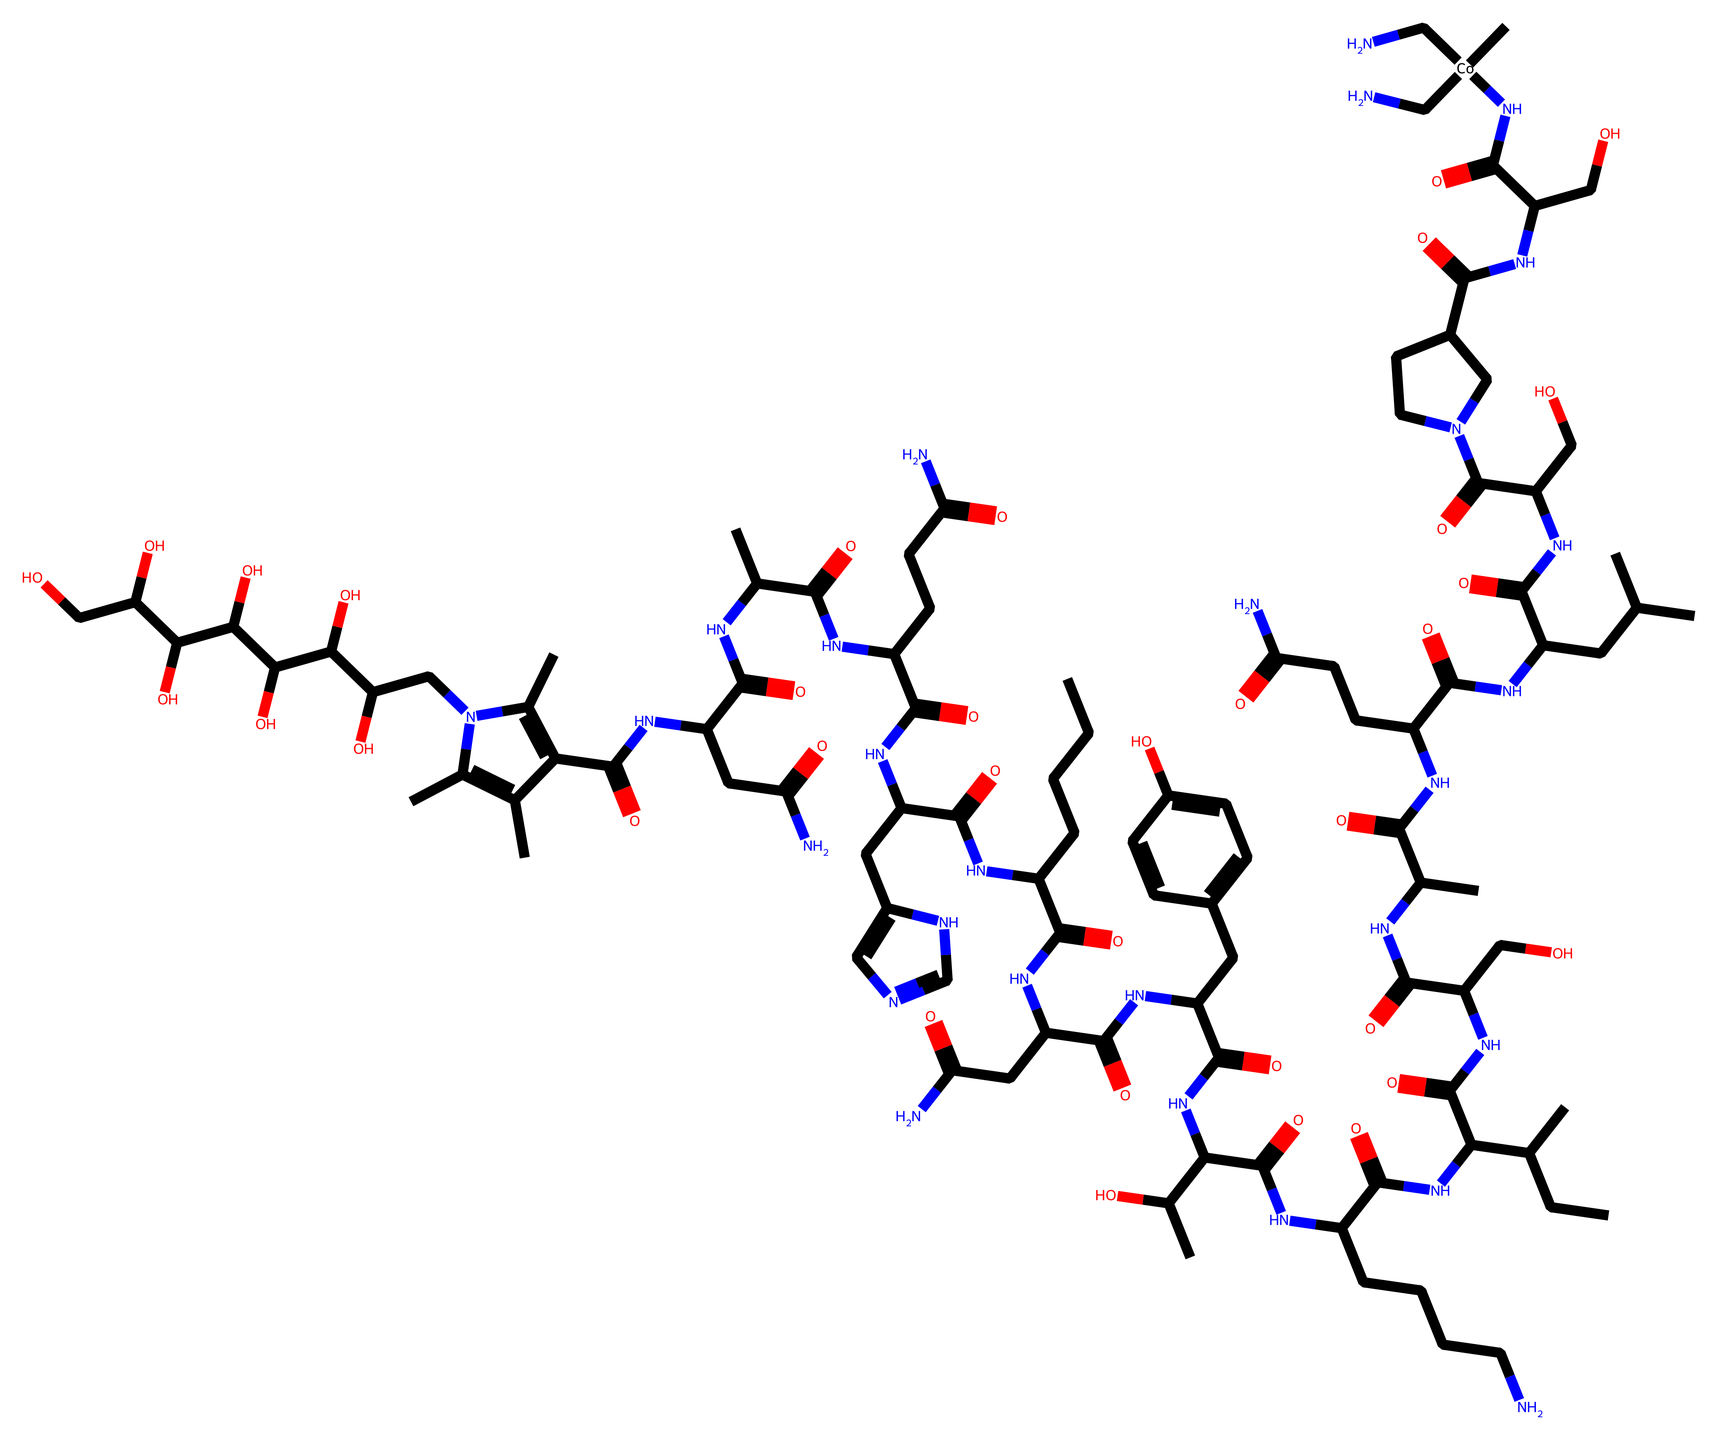What is the central metal in this organometallic compound? The structure includes cobalt (Co) directly connected to the nitrogen atoms from the side chains, indicating that cobalt is the central metal in this compound.
Answer: cobalt How many nitrogen atoms are present in the structure? By inspecting the SMILES representation, there are several nitrogen atoms indicated by the 'N' letter, totaling five distinct nitrogen atoms at various parts of the structure.
Answer: five Is this compound a part of any vitamin category? The compound structure corresponds to methylcobalamin, which is known to be a form of Vitamin B12, indicating that this chemical is indeed part of a vitamin category.
Answer: Vitamin B12 What functional groups are prominent in this chemical? The presence of multiple hydroxyl (-OH) groups and amide (R-C(=O)N-R') linkages suggests that these are the most prominent functional groups present in the compound.
Answer: hydroxyl and amide How does the cobalt atom in this structure influence its biological role? Cobalt is essential for the biological activity of Vitamin B12 where it forms a pivotal role in various enzymatic processes, allowing for critical interaction with the nitrogen-containing components.
Answer: enzymatic interaction What is the primary purpose of methylcobalamin in biological systems? Methylcobalamin primarily serves as a cofactor in enzyme reactions, particularly in the conversion of homocysteine to methionine, which is vital for DNA synthesis and neurological function.
Answer: cofactor for enzyme reactions 